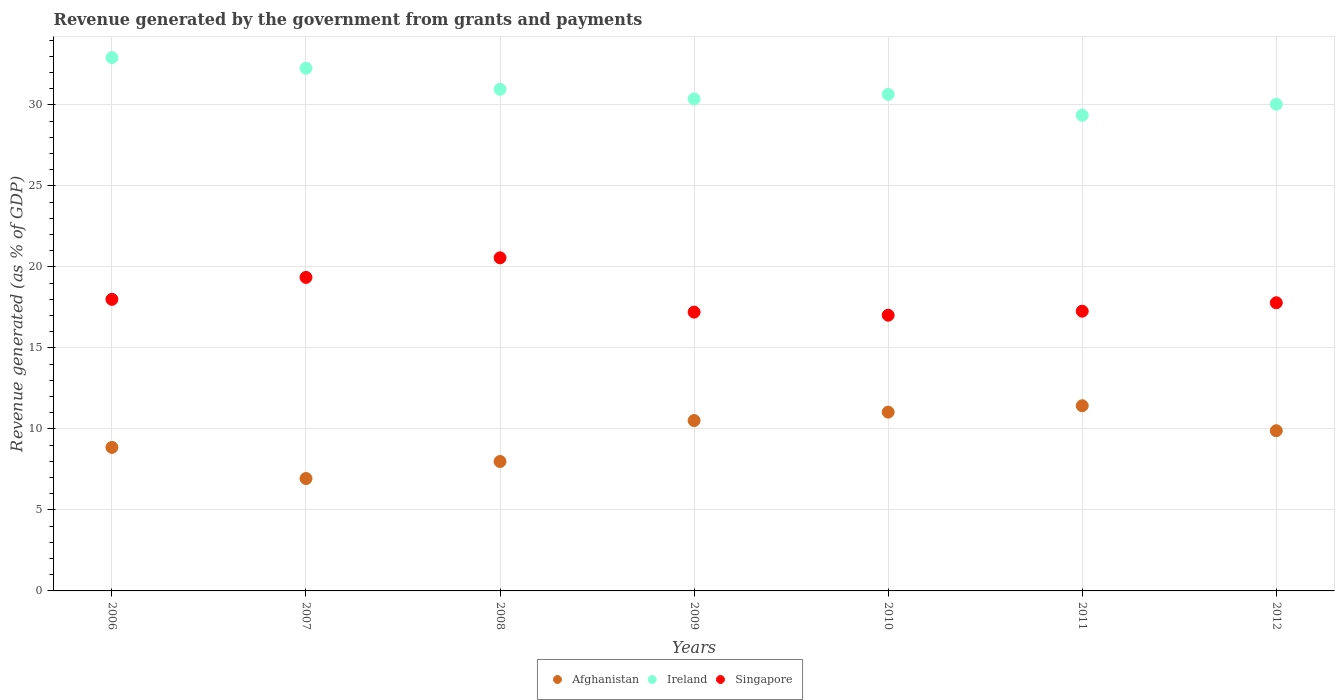Is the number of dotlines equal to the number of legend labels?
Provide a succinct answer. Yes. What is the revenue generated by the government in Singapore in 2012?
Your answer should be very brief. 17.79. Across all years, what is the maximum revenue generated by the government in Ireland?
Offer a terse response. 32.92. Across all years, what is the minimum revenue generated by the government in Singapore?
Offer a terse response. 17.02. What is the total revenue generated by the government in Singapore in the graph?
Give a very brief answer. 127.2. What is the difference between the revenue generated by the government in Singapore in 2006 and that in 2010?
Your answer should be compact. 0.98. What is the difference between the revenue generated by the government in Singapore in 2006 and the revenue generated by the government in Ireland in 2009?
Give a very brief answer. -12.37. What is the average revenue generated by the government in Ireland per year?
Offer a terse response. 30.94. In the year 2011, what is the difference between the revenue generated by the government in Afghanistan and revenue generated by the government in Singapore?
Give a very brief answer. -5.84. What is the ratio of the revenue generated by the government in Ireland in 2006 to that in 2009?
Give a very brief answer. 1.08. What is the difference between the highest and the second highest revenue generated by the government in Afghanistan?
Offer a very short reply. 0.39. What is the difference between the highest and the lowest revenue generated by the government in Ireland?
Provide a short and direct response. 3.56. Is the sum of the revenue generated by the government in Ireland in 2006 and 2009 greater than the maximum revenue generated by the government in Singapore across all years?
Offer a terse response. Yes. Is the revenue generated by the government in Singapore strictly greater than the revenue generated by the government in Ireland over the years?
Offer a terse response. No. How many dotlines are there?
Make the answer very short. 3. How many years are there in the graph?
Provide a succinct answer. 7. What is the difference between two consecutive major ticks on the Y-axis?
Make the answer very short. 5. Does the graph contain any zero values?
Ensure brevity in your answer.  No. Does the graph contain grids?
Offer a terse response. Yes. Where does the legend appear in the graph?
Your response must be concise. Bottom center. What is the title of the graph?
Provide a succinct answer. Revenue generated by the government from grants and payments. Does "Cambodia" appear as one of the legend labels in the graph?
Keep it short and to the point. No. What is the label or title of the Y-axis?
Offer a terse response. Revenue generated (as % of GDP). What is the Revenue generated (as % of GDP) of Afghanistan in 2006?
Provide a short and direct response. 8.86. What is the Revenue generated (as % of GDP) of Ireland in 2006?
Offer a terse response. 32.92. What is the Revenue generated (as % of GDP) of Singapore in 2006?
Make the answer very short. 18. What is the Revenue generated (as % of GDP) in Afghanistan in 2007?
Your answer should be compact. 6.94. What is the Revenue generated (as % of GDP) in Ireland in 2007?
Your answer should be very brief. 32.26. What is the Revenue generated (as % of GDP) in Singapore in 2007?
Your answer should be compact. 19.35. What is the Revenue generated (as % of GDP) of Afghanistan in 2008?
Provide a succinct answer. 7.99. What is the Revenue generated (as % of GDP) in Ireland in 2008?
Your answer should be very brief. 30.96. What is the Revenue generated (as % of GDP) in Singapore in 2008?
Provide a short and direct response. 20.56. What is the Revenue generated (as % of GDP) of Afghanistan in 2009?
Keep it short and to the point. 10.52. What is the Revenue generated (as % of GDP) in Ireland in 2009?
Your answer should be very brief. 30.37. What is the Revenue generated (as % of GDP) of Singapore in 2009?
Provide a succinct answer. 17.21. What is the Revenue generated (as % of GDP) of Afghanistan in 2010?
Your answer should be compact. 11.04. What is the Revenue generated (as % of GDP) in Ireland in 2010?
Your answer should be compact. 30.65. What is the Revenue generated (as % of GDP) of Singapore in 2010?
Provide a short and direct response. 17.02. What is the Revenue generated (as % of GDP) in Afghanistan in 2011?
Make the answer very short. 11.43. What is the Revenue generated (as % of GDP) of Ireland in 2011?
Your answer should be very brief. 29.36. What is the Revenue generated (as % of GDP) in Singapore in 2011?
Make the answer very short. 17.27. What is the Revenue generated (as % of GDP) of Afghanistan in 2012?
Make the answer very short. 9.89. What is the Revenue generated (as % of GDP) in Ireland in 2012?
Your response must be concise. 30.04. What is the Revenue generated (as % of GDP) of Singapore in 2012?
Keep it short and to the point. 17.79. Across all years, what is the maximum Revenue generated (as % of GDP) of Afghanistan?
Ensure brevity in your answer.  11.43. Across all years, what is the maximum Revenue generated (as % of GDP) of Ireland?
Make the answer very short. 32.92. Across all years, what is the maximum Revenue generated (as % of GDP) in Singapore?
Your answer should be very brief. 20.56. Across all years, what is the minimum Revenue generated (as % of GDP) in Afghanistan?
Offer a very short reply. 6.94. Across all years, what is the minimum Revenue generated (as % of GDP) in Ireland?
Offer a very short reply. 29.36. Across all years, what is the minimum Revenue generated (as % of GDP) in Singapore?
Make the answer very short. 17.02. What is the total Revenue generated (as % of GDP) of Afghanistan in the graph?
Give a very brief answer. 66.66. What is the total Revenue generated (as % of GDP) in Ireland in the graph?
Your answer should be compact. 216.56. What is the total Revenue generated (as % of GDP) of Singapore in the graph?
Ensure brevity in your answer.  127.2. What is the difference between the Revenue generated (as % of GDP) of Afghanistan in 2006 and that in 2007?
Keep it short and to the point. 1.92. What is the difference between the Revenue generated (as % of GDP) of Ireland in 2006 and that in 2007?
Offer a terse response. 0.66. What is the difference between the Revenue generated (as % of GDP) of Singapore in 2006 and that in 2007?
Give a very brief answer. -1.35. What is the difference between the Revenue generated (as % of GDP) of Afghanistan in 2006 and that in 2008?
Ensure brevity in your answer.  0.87. What is the difference between the Revenue generated (as % of GDP) of Ireland in 2006 and that in 2008?
Ensure brevity in your answer.  1.96. What is the difference between the Revenue generated (as % of GDP) of Singapore in 2006 and that in 2008?
Your response must be concise. -2.56. What is the difference between the Revenue generated (as % of GDP) of Afghanistan in 2006 and that in 2009?
Provide a succinct answer. -1.66. What is the difference between the Revenue generated (as % of GDP) in Ireland in 2006 and that in 2009?
Your response must be concise. 2.55. What is the difference between the Revenue generated (as % of GDP) in Singapore in 2006 and that in 2009?
Your response must be concise. 0.79. What is the difference between the Revenue generated (as % of GDP) in Afghanistan in 2006 and that in 2010?
Provide a short and direct response. -2.18. What is the difference between the Revenue generated (as % of GDP) of Ireland in 2006 and that in 2010?
Give a very brief answer. 2.27. What is the difference between the Revenue generated (as % of GDP) in Singapore in 2006 and that in 2010?
Ensure brevity in your answer.  0.98. What is the difference between the Revenue generated (as % of GDP) of Afghanistan in 2006 and that in 2011?
Give a very brief answer. -2.57. What is the difference between the Revenue generated (as % of GDP) in Ireland in 2006 and that in 2011?
Provide a succinct answer. 3.56. What is the difference between the Revenue generated (as % of GDP) in Singapore in 2006 and that in 2011?
Make the answer very short. 0.73. What is the difference between the Revenue generated (as % of GDP) of Afghanistan in 2006 and that in 2012?
Your response must be concise. -1.03. What is the difference between the Revenue generated (as % of GDP) of Ireland in 2006 and that in 2012?
Ensure brevity in your answer.  2.88. What is the difference between the Revenue generated (as % of GDP) in Singapore in 2006 and that in 2012?
Make the answer very short. 0.21. What is the difference between the Revenue generated (as % of GDP) of Afghanistan in 2007 and that in 2008?
Your response must be concise. -1.05. What is the difference between the Revenue generated (as % of GDP) in Ireland in 2007 and that in 2008?
Your answer should be compact. 1.3. What is the difference between the Revenue generated (as % of GDP) in Singapore in 2007 and that in 2008?
Your answer should be compact. -1.21. What is the difference between the Revenue generated (as % of GDP) in Afghanistan in 2007 and that in 2009?
Your answer should be very brief. -3.58. What is the difference between the Revenue generated (as % of GDP) in Ireland in 2007 and that in 2009?
Provide a short and direct response. 1.89. What is the difference between the Revenue generated (as % of GDP) in Singapore in 2007 and that in 2009?
Ensure brevity in your answer.  2.14. What is the difference between the Revenue generated (as % of GDP) in Afghanistan in 2007 and that in 2010?
Your answer should be very brief. -4.1. What is the difference between the Revenue generated (as % of GDP) in Ireland in 2007 and that in 2010?
Make the answer very short. 1.62. What is the difference between the Revenue generated (as % of GDP) of Singapore in 2007 and that in 2010?
Offer a terse response. 2.33. What is the difference between the Revenue generated (as % of GDP) of Afghanistan in 2007 and that in 2011?
Ensure brevity in your answer.  -4.49. What is the difference between the Revenue generated (as % of GDP) in Ireland in 2007 and that in 2011?
Offer a very short reply. 2.9. What is the difference between the Revenue generated (as % of GDP) in Singapore in 2007 and that in 2011?
Offer a very short reply. 2.09. What is the difference between the Revenue generated (as % of GDP) of Afghanistan in 2007 and that in 2012?
Offer a very short reply. -2.95. What is the difference between the Revenue generated (as % of GDP) of Ireland in 2007 and that in 2012?
Your response must be concise. 2.22. What is the difference between the Revenue generated (as % of GDP) of Singapore in 2007 and that in 2012?
Your response must be concise. 1.57. What is the difference between the Revenue generated (as % of GDP) of Afghanistan in 2008 and that in 2009?
Offer a terse response. -2.53. What is the difference between the Revenue generated (as % of GDP) of Ireland in 2008 and that in 2009?
Offer a very short reply. 0.59. What is the difference between the Revenue generated (as % of GDP) of Singapore in 2008 and that in 2009?
Ensure brevity in your answer.  3.35. What is the difference between the Revenue generated (as % of GDP) in Afghanistan in 2008 and that in 2010?
Provide a short and direct response. -3.05. What is the difference between the Revenue generated (as % of GDP) in Ireland in 2008 and that in 2010?
Keep it short and to the point. 0.31. What is the difference between the Revenue generated (as % of GDP) in Singapore in 2008 and that in 2010?
Keep it short and to the point. 3.54. What is the difference between the Revenue generated (as % of GDP) of Afghanistan in 2008 and that in 2011?
Keep it short and to the point. -3.44. What is the difference between the Revenue generated (as % of GDP) in Ireland in 2008 and that in 2011?
Provide a succinct answer. 1.6. What is the difference between the Revenue generated (as % of GDP) of Singapore in 2008 and that in 2011?
Your answer should be very brief. 3.29. What is the difference between the Revenue generated (as % of GDP) of Afghanistan in 2008 and that in 2012?
Keep it short and to the point. -1.9. What is the difference between the Revenue generated (as % of GDP) of Ireland in 2008 and that in 2012?
Your response must be concise. 0.92. What is the difference between the Revenue generated (as % of GDP) of Singapore in 2008 and that in 2012?
Provide a short and direct response. 2.77. What is the difference between the Revenue generated (as % of GDP) in Afghanistan in 2009 and that in 2010?
Offer a terse response. -0.52. What is the difference between the Revenue generated (as % of GDP) of Ireland in 2009 and that in 2010?
Your answer should be compact. -0.28. What is the difference between the Revenue generated (as % of GDP) in Singapore in 2009 and that in 2010?
Your answer should be compact. 0.19. What is the difference between the Revenue generated (as % of GDP) of Afghanistan in 2009 and that in 2011?
Give a very brief answer. -0.91. What is the difference between the Revenue generated (as % of GDP) of Ireland in 2009 and that in 2011?
Offer a terse response. 1.01. What is the difference between the Revenue generated (as % of GDP) in Singapore in 2009 and that in 2011?
Give a very brief answer. -0.06. What is the difference between the Revenue generated (as % of GDP) of Afghanistan in 2009 and that in 2012?
Give a very brief answer. 0.63. What is the difference between the Revenue generated (as % of GDP) of Ireland in 2009 and that in 2012?
Your answer should be compact. 0.33. What is the difference between the Revenue generated (as % of GDP) of Singapore in 2009 and that in 2012?
Keep it short and to the point. -0.58. What is the difference between the Revenue generated (as % of GDP) of Afghanistan in 2010 and that in 2011?
Your answer should be very brief. -0.39. What is the difference between the Revenue generated (as % of GDP) in Ireland in 2010 and that in 2011?
Provide a succinct answer. 1.29. What is the difference between the Revenue generated (as % of GDP) in Singapore in 2010 and that in 2011?
Keep it short and to the point. -0.25. What is the difference between the Revenue generated (as % of GDP) of Afghanistan in 2010 and that in 2012?
Ensure brevity in your answer.  1.15. What is the difference between the Revenue generated (as % of GDP) in Ireland in 2010 and that in 2012?
Ensure brevity in your answer.  0.61. What is the difference between the Revenue generated (as % of GDP) of Singapore in 2010 and that in 2012?
Provide a short and direct response. -0.77. What is the difference between the Revenue generated (as % of GDP) in Afghanistan in 2011 and that in 2012?
Make the answer very short. 1.54. What is the difference between the Revenue generated (as % of GDP) in Ireland in 2011 and that in 2012?
Give a very brief answer. -0.68. What is the difference between the Revenue generated (as % of GDP) in Singapore in 2011 and that in 2012?
Keep it short and to the point. -0.52. What is the difference between the Revenue generated (as % of GDP) of Afghanistan in 2006 and the Revenue generated (as % of GDP) of Ireland in 2007?
Ensure brevity in your answer.  -23.4. What is the difference between the Revenue generated (as % of GDP) in Afghanistan in 2006 and the Revenue generated (as % of GDP) in Singapore in 2007?
Your response must be concise. -10.49. What is the difference between the Revenue generated (as % of GDP) of Ireland in 2006 and the Revenue generated (as % of GDP) of Singapore in 2007?
Your response must be concise. 13.57. What is the difference between the Revenue generated (as % of GDP) of Afghanistan in 2006 and the Revenue generated (as % of GDP) of Ireland in 2008?
Your answer should be compact. -22.1. What is the difference between the Revenue generated (as % of GDP) of Afghanistan in 2006 and the Revenue generated (as % of GDP) of Singapore in 2008?
Your answer should be very brief. -11.7. What is the difference between the Revenue generated (as % of GDP) of Ireland in 2006 and the Revenue generated (as % of GDP) of Singapore in 2008?
Your answer should be compact. 12.36. What is the difference between the Revenue generated (as % of GDP) in Afghanistan in 2006 and the Revenue generated (as % of GDP) in Ireland in 2009?
Your answer should be very brief. -21.51. What is the difference between the Revenue generated (as % of GDP) in Afghanistan in 2006 and the Revenue generated (as % of GDP) in Singapore in 2009?
Ensure brevity in your answer.  -8.35. What is the difference between the Revenue generated (as % of GDP) of Ireland in 2006 and the Revenue generated (as % of GDP) of Singapore in 2009?
Your answer should be very brief. 15.71. What is the difference between the Revenue generated (as % of GDP) of Afghanistan in 2006 and the Revenue generated (as % of GDP) of Ireland in 2010?
Keep it short and to the point. -21.79. What is the difference between the Revenue generated (as % of GDP) in Afghanistan in 2006 and the Revenue generated (as % of GDP) in Singapore in 2010?
Your answer should be compact. -8.16. What is the difference between the Revenue generated (as % of GDP) in Ireland in 2006 and the Revenue generated (as % of GDP) in Singapore in 2010?
Keep it short and to the point. 15.9. What is the difference between the Revenue generated (as % of GDP) of Afghanistan in 2006 and the Revenue generated (as % of GDP) of Ireland in 2011?
Make the answer very short. -20.5. What is the difference between the Revenue generated (as % of GDP) of Afghanistan in 2006 and the Revenue generated (as % of GDP) of Singapore in 2011?
Offer a very short reply. -8.41. What is the difference between the Revenue generated (as % of GDP) of Ireland in 2006 and the Revenue generated (as % of GDP) of Singapore in 2011?
Provide a succinct answer. 15.65. What is the difference between the Revenue generated (as % of GDP) in Afghanistan in 2006 and the Revenue generated (as % of GDP) in Ireland in 2012?
Provide a succinct answer. -21.18. What is the difference between the Revenue generated (as % of GDP) in Afghanistan in 2006 and the Revenue generated (as % of GDP) in Singapore in 2012?
Offer a terse response. -8.93. What is the difference between the Revenue generated (as % of GDP) of Ireland in 2006 and the Revenue generated (as % of GDP) of Singapore in 2012?
Ensure brevity in your answer.  15.13. What is the difference between the Revenue generated (as % of GDP) in Afghanistan in 2007 and the Revenue generated (as % of GDP) in Ireland in 2008?
Keep it short and to the point. -24.02. What is the difference between the Revenue generated (as % of GDP) in Afghanistan in 2007 and the Revenue generated (as % of GDP) in Singapore in 2008?
Ensure brevity in your answer.  -13.62. What is the difference between the Revenue generated (as % of GDP) in Ireland in 2007 and the Revenue generated (as % of GDP) in Singapore in 2008?
Ensure brevity in your answer.  11.7. What is the difference between the Revenue generated (as % of GDP) of Afghanistan in 2007 and the Revenue generated (as % of GDP) of Ireland in 2009?
Offer a terse response. -23.43. What is the difference between the Revenue generated (as % of GDP) of Afghanistan in 2007 and the Revenue generated (as % of GDP) of Singapore in 2009?
Offer a terse response. -10.27. What is the difference between the Revenue generated (as % of GDP) of Ireland in 2007 and the Revenue generated (as % of GDP) of Singapore in 2009?
Provide a short and direct response. 15.05. What is the difference between the Revenue generated (as % of GDP) of Afghanistan in 2007 and the Revenue generated (as % of GDP) of Ireland in 2010?
Your response must be concise. -23.71. What is the difference between the Revenue generated (as % of GDP) of Afghanistan in 2007 and the Revenue generated (as % of GDP) of Singapore in 2010?
Give a very brief answer. -10.08. What is the difference between the Revenue generated (as % of GDP) of Ireland in 2007 and the Revenue generated (as % of GDP) of Singapore in 2010?
Offer a terse response. 15.24. What is the difference between the Revenue generated (as % of GDP) of Afghanistan in 2007 and the Revenue generated (as % of GDP) of Ireland in 2011?
Your answer should be compact. -22.42. What is the difference between the Revenue generated (as % of GDP) of Afghanistan in 2007 and the Revenue generated (as % of GDP) of Singapore in 2011?
Give a very brief answer. -10.33. What is the difference between the Revenue generated (as % of GDP) in Ireland in 2007 and the Revenue generated (as % of GDP) in Singapore in 2011?
Your answer should be very brief. 15. What is the difference between the Revenue generated (as % of GDP) of Afghanistan in 2007 and the Revenue generated (as % of GDP) of Ireland in 2012?
Give a very brief answer. -23.1. What is the difference between the Revenue generated (as % of GDP) of Afghanistan in 2007 and the Revenue generated (as % of GDP) of Singapore in 2012?
Offer a terse response. -10.85. What is the difference between the Revenue generated (as % of GDP) of Ireland in 2007 and the Revenue generated (as % of GDP) of Singapore in 2012?
Ensure brevity in your answer.  14.48. What is the difference between the Revenue generated (as % of GDP) of Afghanistan in 2008 and the Revenue generated (as % of GDP) of Ireland in 2009?
Offer a terse response. -22.38. What is the difference between the Revenue generated (as % of GDP) in Afghanistan in 2008 and the Revenue generated (as % of GDP) in Singapore in 2009?
Keep it short and to the point. -9.22. What is the difference between the Revenue generated (as % of GDP) in Ireland in 2008 and the Revenue generated (as % of GDP) in Singapore in 2009?
Your response must be concise. 13.75. What is the difference between the Revenue generated (as % of GDP) in Afghanistan in 2008 and the Revenue generated (as % of GDP) in Ireland in 2010?
Your response must be concise. -22.66. What is the difference between the Revenue generated (as % of GDP) in Afghanistan in 2008 and the Revenue generated (as % of GDP) in Singapore in 2010?
Offer a very short reply. -9.03. What is the difference between the Revenue generated (as % of GDP) in Ireland in 2008 and the Revenue generated (as % of GDP) in Singapore in 2010?
Keep it short and to the point. 13.94. What is the difference between the Revenue generated (as % of GDP) in Afghanistan in 2008 and the Revenue generated (as % of GDP) in Ireland in 2011?
Your response must be concise. -21.37. What is the difference between the Revenue generated (as % of GDP) of Afghanistan in 2008 and the Revenue generated (as % of GDP) of Singapore in 2011?
Your response must be concise. -9.28. What is the difference between the Revenue generated (as % of GDP) of Ireland in 2008 and the Revenue generated (as % of GDP) of Singapore in 2011?
Ensure brevity in your answer.  13.69. What is the difference between the Revenue generated (as % of GDP) of Afghanistan in 2008 and the Revenue generated (as % of GDP) of Ireland in 2012?
Give a very brief answer. -22.05. What is the difference between the Revenue generated (as % of GDP) in Afghanistan in 2008 and the Revenue generated (as % of GDP) in Singapore in 2012?
Give a very brief answer. -9.8. What is the difference between the Revenue generated (as % of GDP) in Ireland in 2008 and the Revenue generated (as % of GDP) in Singapore in 2012?
Provide a succinct answer. 13.17. What is the difference between the Revenue generated (as % of GDP) of Afghanistan in 2009 and the Revenue generated (as % of GDP) of Ireland in 2010?
Ensure brevity in your answer.  -20.13. What is the difference between the Revenue generated (as % of GDP) of Afghanistan in 2009 and the Revenue generated (as % of GDP) of Singapore in 2010?
Keep it short and to the point. -6.5. What is the difference between the Revenue generated (as % of GDP) of Ireland in 2009 and the Revenue generated (as % of GDP) of Singapore in 2010?
Your answer should be very brief. 13.35. What is the difference between the Revenue generated (as % of GDP) in Afghanistan in 2009 and the Revenue generated (as % of GDP) in Ireland in 2011?
Your response must be concise. -18.85. What is the difference between the Revenue generated (as % of GDP) in Afghanistan in 2009 and the Revenue generated (as % of GDP) in Singapore in 2011?
Give a very brief answer. -6.75. What is the difference between the Revenue generated (as % of GDP) in Ireland in 2009 and the Revenue generated (as % of GDP) in Singapore in 2011?
Provide a succinct answer. 13.1. What is the difference between the Revenue generated (as % of GDP) in Afghanistan in 2009 and the Revenue generated (as % of GDP) in Ireland in 2012?
Provide a short and direct response. -19.52. What is the difference between the Revenue generated (as % of GDP) of Afghanistan in 2009 and the Revenue generated (as % of GDP) of Singapore in 2012?
Your answer should be compact. -7.27. What is the difference between the Revenue generated (as % of GDP) in Ireland in 2009 and the Revenue generated (as % of GDP) in Singapore in 2012?
Your answer should be very brief. 12.58. What is the difference between the Revenue generated (as % of GDP) of Afghanistan in 2010 and the Revenue generated (as % of GDP) of Ireland in 2011?
Provide a succinct answer. -18.33. What is the difference between the Revenue generated (as % of GDP) of Afghanistan in 2010 and the Revenue generated (as % of GDP) of Singapore in 2011?
Make the answer very short. -6.23. What is the difference between the Revenue generated (as % of GDP) of Ireland in 2010 and the Revenue generated (as % of GDP) of Singapore in 2011?
Your response must be concise. 13.38. What is the difference between the Revenue generated (as % of GDP) in Afghanistan in 2010 and the Revenue generated (as % of GDP) in Ireland in 2012?
Offer a terse response. -19. What is the difference between the Revenue generated (as % of GDP) in Afghanistan in 2010 and the Revenue generated (as % of GDP) in Singapore in 2012?
Keep it short and to the point. -6.75. What is the difference between the Revenue generated (as % of GDP) of Ireland in 2010 and the Revenue generated (as % of GDP) of Singapore in 2012?
Give a very brief answer. 12.86. What is the difference between the Revenue generated (as % of GDP) of Afghanistan in 2011 and the Revenue generated (as % of GDP) of Ireland in 2012?
Your answer should be very brief. -18.61. What is the difference between the Revenue generated (as % of GDP) of Afghanistan in 2011 and the Revenue generated (as % of GDP) of Singapore in 2012?
Ensure brevity in your answer.  -6.36. What is the difference between the Revenue generated (as % of GDP) in Ireland in 2011 and the Revenue generated (as % of GDP) in Singapore in 2012?
Provide a short and direct response. 11.57. What is the average Revenue generated (as % of GDP) of Afghanistan per year?
Ensure brevity in your answer.  9.52. What is the average Revenue generated (as % of GDP) in Ireland per year?
Provide a succinct answer. 30.94. What is the average Revenue generated (as % of GDP) of Singapore per year?
Provide a succinct answer. 18.17. In the year 2006, what is the difference between the Revenue generated (as % of GDP) of Afghanistan and Revenue generated (as % of GDP) of Ireland?
Your answer should be very brief. -24.06. In the year 2006, what is the difference between the Revenue generated (as % of GDP) in Afghanistan and Revenue generated (as % of GDP) in Singapore?
Offer a terse response. -9.14. In the year 2006, what is the difference between the Revenue generated (as % of GDP) in Ireland and Revenue generated (as % of GDP) in Singapore?
Your answer should be compact. 14.92. In the year 2007, what is the difference between the Revenue generated (as % of GDP) in Afghanistan and Revenue generated (as % of GDP) in Ireland?
Give a very brief answer. -25.32. In the year 2007, what is the difference between the Revenue generated (as % of GDP) in Afghanistan and Revenue generated (as % of GDP) in Singapore?
Give a very brief answer. -12.42. In the year 2007, what is the difference between the Revenue generated (as % of GDP) of Ireland and Revenue generated (as % of GDP) of Singapore?
Offer a very short reply. 12.91. In the year 2008, what is the difference between the Revenue generated (as % of GDP) of Afghanistan and Revenue generated (as % of GDP) of Ireland?
Provide a succinct answer. -22.97. In the year 2008, what is the difference between the Revenue generated (as % of GDP) in Afghanistan and Revenue generated (as % of GDP) in Singapore?
Provide a short and direct response. -12.57. In the year 2008, what is the difference between the Revenue generated (as % of GDP) of Ireland and Revenue generated (as % of GDP) of Singapore?
Make the answer very short. 10.4. In the year 2009, what is the difference between the Revenue generated (as % of GDP) in Afghanistan and Revenue generated (as % of GDP) in Ireland?
Your answer should be compact. -19.85. In the year 2009, what is the difference between the Revenue generated (as % of GDP) in Afghanistan and Revenue generated (as % of GDP) in Singapore?
Give a very brief answer. -6.69. In the year 2009, what is the difference between the Revenue generated (as % of GDP) in Ireland and Revenue generated (as % of GDP) in Singapore?
Your answer should be compact. 13.16. In the year 2010, what is the difference between the Revenue generated (as % of GDP) in Afghanistan and Revenue generated (as % of GDP) in Ireland?
Offer a very short reply. -19.61. In the year 2010, what is the difference between the Revenue generated (as % of GDP) of Afghanistan and Revenue generated (as % of GDP) of Singapore?
Ensure brevity in your answer.  -5.98. In the year 2010, what is the difference between the Revenue generated (as % of GDP) in Ireland and Revenue generated (as % of GDP) in Singapore?
Keep it short and to the point. 13.63. In the year 2011, what is the difference between the Revenue generated (as % of GDP) of Afghanistan and Revenue generated (as % of GDP) of Ireland?
Provide a succinct answer. -17.93. In the year 2011, what is the difference between the Revenue generated (as % of GDP) in Afghanistan and Revenue generated (as % of GDP) in Singapore?
Your answer should be compact. -5.84. In the year 2011, what is the difference between the Revenue generated (as % of GDP) of Ireland and Revenue generated (as % of GDP) of Singapore?
Your answer should be very brief. 12.09. In the year 2012, what is the difference between the Revenue generated (as % of GDP) of Afghanistan and Revenue generated (as % of GDP) of Ireland?
Your answer should be very brief. -20.15. In the year 2012, what is the difference between the Revenue generated (as % of GDP) of Afghanistan and Revenue generated (as % of GDP) of Singapore?
Your response must be concise. -7.9. In the year 2012, what is the difference between the Revenue generated (as % of GDP) of Ireland and Revenue generated (as % of GDP) of Singapore?
Offer a terse response. 12.25. What is the ratio of the Revenue generated (as % of GDP) of Afghanistan in 2006 to that in 2007?
Give a very brief answer. 1.28. What is the ratio of the Revenue generated (as % of GDP) of Ireland in 2006 to that in 2007?
Ensure brevity in your answer.  1.02. What is the ratio of the Revenue generated (as % of GDP) in Singapore in 2006 to that in 2007?
Give a very brief answer. 0.93. What is the ratio of the Revenue generated (as % of GDP) of Afghanistan in 2006 to that in 2008?
Make the answer very short. 1.11. What is the ratio of the Revenue generated (as % of GDP) in Ireland in 2006 to that in 2008?
Provide a short and direct response. 1.06. What is the ratio of the Revenue generated (as % of GDP) in Singapore in 2006 to that in 2008?
Ensure brevity in your answer.  0.88. What is the ratio of the Revenue generated (as % of GDP) of Afghanistan in 2006 to that in 2009?
Provide a succinct answer. 0.84. What is the ratio of the Revenue generated (as % of GDP) of Ireland in 2006 to that in 2009?
Offer a very short reply. 1.08. What is the ratio of the Revenue generated (as % of GDP) in Singapore in 2006 to that in 2009?
Offer a very short reply. 1.05. What is the ratio of the Revenue generated (as % of GDP) in Afghanistan in 2006 to that in 2010?
Offer a terse response. 0.8. What is the ratio of the Revenue generated (as % of GDP) in Ireland in 2006 to that in 2010?
Your answer should be very brief. 1.07. What is the ratio of the Revenue generated (as % of GDP) of Singapore in 2006 to that in 2010?
Ensure brevity in your answer.  1.06. What is the ratio of the Revenue generated (as % of GDP) in Afghanistan in 2006 to that in 2011?
Offer a very short reply. 0.78. What is the ratio of the Revenue generated (as % of GDP) of Ireland in 2006 to that in 2011?
Offer a very short reply. 1.12. What is the ratio of the Revenue generated (as % of GDP) in Singapore in 2006 to that in 2011?
Your answer should be compact. 1.04. What is the ratio of the Revenue generated (as % of GDP) of Afghanistan in 2006 to that in 2012?
Your answer should be very brief. 0.9. What is the ratio of the Revenue generated (as % of GDP) in Ireland in 2006 to that in 2012?
Give a very brief answer. 1.1. What is the ratio of the Revenue generated (as % of GDP) of Singapore in 2006 to that in 2012?
Provide a short and direct response. 1.01. What is the ratio of the Revenue generated (as % of GDP) in Afghanistan in 2007 to that in 2008?
Your answer should be very brief. 0.87. What is the ratio of the Revenue generated (as % of GDP) in Ireland in 2007 to that in 2008?
Give a very brief answer. 1.04. What is the ratio of the Revenue generated (as % of GDP) in Singapore in 2007 to that in 2008?
Ensure brevity in your answer.  0.94. What is the ratio of the Revenue generated (as % of GDP) of Afghanistan in 2007 to that in 2009?
Offer a terse response. 0.66. What is the ratio of the Revenue generated (as % of GDP) of Ireland in 2007 to that in 2009?
Offer a very short reply. 1.06. What is the ratio of the Revenue generated (as % of GDP) in Singapore in 2007 to that in 2009?
Your answer should be very brief. 1.12. What is the ratio of the Revenue generated (as % of GDP) of Afghanistan in 2007 to that in 2010?
Keep it short and to the point. 0.63. What is the ratio of the Revenue generated (as % of GDP) of Ireland in 2007 to that in 2010?
Your answer should be very brief. 1.05. What is the ratio of the Revenue generated (as % of GDP) in Singapore in 2007 to that in 2010?
Give a very brief answer. 1.14. What is the ratio of the Revenue generated (as % of GDP) in Afghanistan in 2007 to that in 2011?
Ensure brevity in your answer.  0.61. What is the ratio of the Revenue generated (as % of GDP) in Ireland in 2007 to that in 2011?
Offer a very short reply. 1.1. What is the ratio of the Revenue generated (as % of GDP) in Singapore in 2007 to that in 2011?
Your answer should be very brief. 1.12. What is the ratio of the Revenue generated (as % of GDP) in Afghanistan in 2007 to that in 2012?
Offer a terse response. 0.7. What is the ratio of the Revenue generated (as % of GDP) in Ireland in 2007 to that in 2012?
Provide a succinct answer. 1.07. What is the ratio of the Revenue generated (as % of GDP) of Singapore in 2007 to that in 2012?
Your response must be concise. 1.09. What is the ratio of the Revenue generated (as % of GDP) in Afghanistan in 2008 to that in 2009?
Make the answer very short. 0.76. What is the ratio of the Revenue generated (as % of GDP) in Ireland in 2008 to that in 2009?
Offer a very short reply. 1.02. What is the ratio of the Revenue generated (as % of GDP) in Singapore in 2008 to that in 2009?
Ensure brevity in your answer.  1.19. What is the ratio of the Revenue generated (as % of GDP) of Afghanistan in 2008 to that in 2010?
Keep it short and to the point. 0.72. What is the ratio of the Revenue generated (as % of GDP) of Ireland in 2008 to that in 2010?
Offer a very short reply. 1.01. What is the ratio of the Revenue generated (as % of GDP) in Singapore in 2008 to that in 2010?
Offer a very short reply. 1.21. What is the ratio of the Revenue generated (as % of GDP) of Afghanistan in 2008 to that in 2011?
Give a very brief answer. 0.7. What is the ratio of the Revenue generated (as % of GDP) of Ireland in 2008 to that in 2011?
Provide a short and direct response. 1.05. What is the ratio of the Revenue generated (as % of GDP) of Singapore in 2008 to that in 2011?
Make the answer very short. 1.19. What is the ratio of the Revenue generated (as % of GDP) in Afghanistan in 2008 to that in 2012?
Provide a short and direct response. 0.81. What is the ratio of the Revenue generated (as % of GDP) of Ireland in 2008 to that in 2012?
Keep it short and to the point. 1.03. What is the ratio of the Revenue generated (as % of GDP) in Singapore in 2008 to that in 2012?
Offer a terse response. 1.16. What is the ratio of the Revenue generated (as % of GDP) of Afghanistan in 2009 to that in 2010?
Your answer should be very brief. 0.95. What is the ratio of the Revenue generated (as % of GDP) of Ireland in 2009 to that in 2010?
Your response must be concise. 0.99. What is the ratio of the Revenue generated (as % of GDP) in Singapore in 2009 to that in 2010?
Offer a terse response. 1.01. What is the ratio of the Revenue generated (as % of GDP) of Afghanistan in 2009 to that in 2011?
Provide a succinct answer. 0.92. What is the ratio of the Revenue generated (as % of GDP) in Ireland in 2009 to that in 2011?
Offer a very short reply. 1.03. What is the ratio of the Revenue generated (as % of GDP) in Singapore in 2009 to that in 2011?
Your answer should be very brief. 1. What is the ratio of the Revenue generated (as % of GDP) of Afghanistan in 2009 to that in 2012?
Provide a succinct answer. 1.06. What is the ratio of the Revenue generated (as % of GDP) of Ireland in 2009 to that in 2012?
Offer a terse response. 1.01. What is the ratio of the Revenue generated (as % of GDP) in Singapore in 2009 to that in 2012?
Keep it short and to the point. 0.97. What is the ratio of the Revenue generated (as % of GDP) in Afghanistan in 2010 to that in 2011?
Provide a short and direct response. 0.97. What is the ratio of the Revenue generated (as % of GDP) of Ireland in 2010 to that in 2011?
Make the answer very short. 1.04. What is the ratio of the Revenue generated (as % of GDP) in Singapore in 2010 to that in 2011?
Give a very brief answer. 0.99. What is the ratio of the Revenue generated (as % of GDP) in Afghanistan in 2010 to that in 2012?
Keep it short and to the point. 1.12. What is the ratio of the Revenue generated (as % of GDP) in Ireland in 2010 to that in 2012?
Keep it short and to the point. 1.02. What is the ratio of the Revenue generated (as % of GDP) of Singapore in 2010 to that in 2012?
Give a very brief answer. 0.96. What is the ratio of the Revenue generated (as % of GDP) of Afghanistan in 2011 to that in 2012?
Keep it short and to the point. 1.16. What is the ratio of the Revenue generated (as % of GDP) in Ireland in 2011 to that in 2012?
Provide a succinct answer. 0.98. What is the ratio of the Revenue generated (as % of GDP) in Singapore in 2011 to that in 2012?
Give a very brief answer. 0.97. What is the difference between the highest and the second highest Revenue generated (as % of GDP) in Afghanistan?
Keep it short and to the point. 0.39. What is the difference between the highest and the second highest Revenue generated (as % of GDP) of Ireland?
Offer a terse response. 0.66. What is the difference between the highest and the second highest Revenue generated (as % of GDP) in Singapore?
Your answer should be compact. 1.21. What is the difference between the highest and the lowest Revenue generated (as % of GDP) of Afghanistan?
Provide a succinct answer. 4.49. What is the difference between the highest and the lowest Revenue generated (as % of GDP) of Ireland?
Provide a short and direct response. 3.56. What is the difference between the highest and the lowest Revenue generated (as % of GDP) of Singapore?
Your answer should be compact. 3.54. 